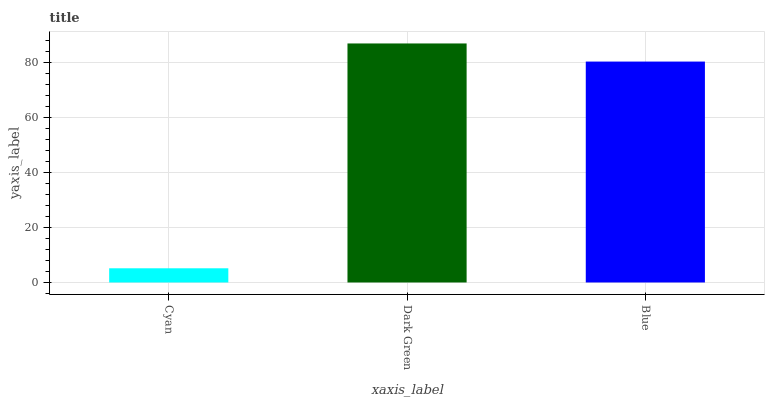Is Cyan the minimum?
Answer yes or no. Yes. Is Dark Green the maximum?
Answer yes or no. Yes. Is Blue the minimum?
Answer yes or no. No. Is Blue the maximum?
Answer yes or no. No. Is Dark Green greater than Blue?
Answer yes or no. Yes. Is Blue less than Dark Green?
Answer yes or no. Yes. Is Blue greater than Dark Green?
Answer yes or no. No. Is Dark Green less than Blue?
Answer yes or no. No. Is Blue the high median?
Answer yes or no. Yes. Is Blue the low median?
Answer yes or no. Yes. Is Cyan the high median?
Answer yes or no. No. Is Dark Green the low median?
Answer yes or no. No. 